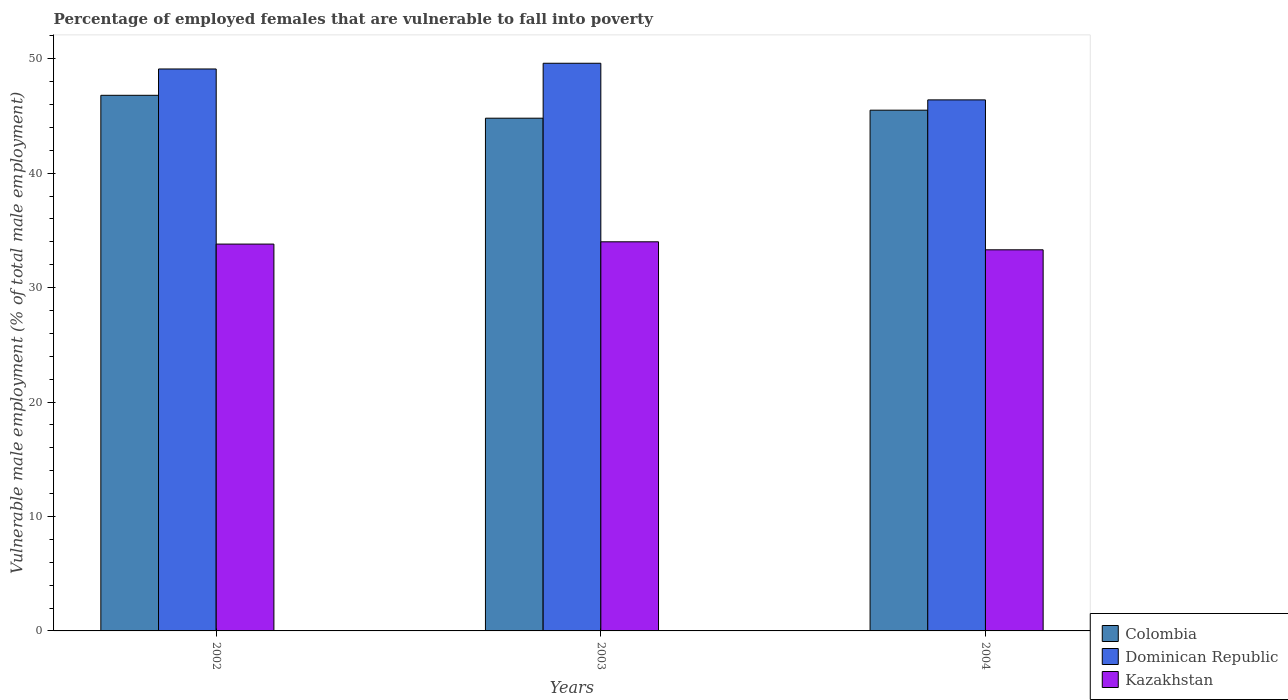How many groups of bars are there?
Your answer should be very brief. 3. Are the number of bars per tick equal to the number of legend labels?
Your response must be concise. Yes. Are the number of bars on each tick of the X-axis equal?
Provide a short and direct response. Yes. How many bars are there on the 3rd tick from the left?
Provide a succinct answer. 3. What is the percentage of employed females who are vulnerable to fall into poverty in Dominican Republic in 2003?
Keep it short and to the point. 49.6. Across all years, what is the minimum percentage of employed females who are vulnerable to fall into poverty in Dominican Republic?
Provide a succinct answer. 46.4. In which year was the percentage of employed females who are vulnerable to fall into poverty in Colombia maximum?
Give a very brief answer. 2002. In which year was the percentage of employed females who are vulnerable to fall into poverty in Dominican Republic minimum?
Make the answer very short. 2004. What is the total percentage of employed females who are vulnerable to fall into poverty in Dominican Republic in the graph?
Ensure brevity in your answer.  145.1. What is the difference between the percentage of employed females who are vulnerable to fall into poverty in Dominican Republic in 2003 and that in 2004?
Keep it short and to the point. 3.2. What is the difference between the percentage of employed females who are vulnerable to fall into poverty in Colombia in 2003 and the percentage of employed females who are vulnerable to fall into poverty in Kazakhstan in 2004?
Your response must be concise. 11.5. What is the average percentage of employed females who are vulnerable to fall into poverty in Colombia per year?
Give a very brief answer. 45.7. In the year 2002, what is the difference between the percentage of employed females who are vulnerable to fall into poverty in Dominican Republic and percentage of employed females who are vulnerable to fall into poverty in Colombia?
Provide a short and direct response. 2.3. In how many years, is the percentage of employed females who are vulnerable to fall into poverty in Kazakhstan greater than 18 %?
Provide a short and direct response. 3. What is the ratio of the percentage of employed females who are vulnerable to fall into poverty in Colombia in 2002 to that in 2004?
Your answer should be very brief. 1.03. What is the difference between the highest and the second highest percentage of employed females who are vulnerable to fall into poverty in Colombia?
Provide a short and direct response. 1.3. In how many years, is the percentage of employed females who are vulnerable to fall into poverty in Dominican Republic greater than the average percentage of employed females who are vulnerable to fall into poverty in Dominican Republic taken over all years?
Offer a terse response. 2. Is the sum of the percentage of employed females who are vulnerable to fall into poverty in Colombia in 2002 and 2003 greater than the maximum percentage of employed females who are vulnerable to fall into poverty in Kazakhstan across all years?
Provide a succinct answer. Yes. What does the 3rd bar from the left in 2004 represents?
Your response must be concise. Kazakhstan. What does the 1st bar from the right in 2003 represents?
Give a very brief answer. Kazakhstan. Is it the case that in every year, the sum of the percentage of employed females who are vulnerable to fall into poverty in Dominican Republic and percentage of employed females who are vulnerable to fall into poverty in Colombia is greater than the percentage of employed females who are vulnerable to fall into poverty in Kazakhstan?
Provide a succinct answer. Yes. What is the difference between two consecutive major ticks on the Y-axis?
Provide a short and direct response. 10. Does the graph contain grids?
Provide a succinct answer. No. How many legend labels are there?
Your response must be concise. 3. What is the title of the graph?
Your answer should be very brief. Percentage of employed females that are vulnerable to fall into poverty. Does "Colombia" appear as one of the legend labels in the graph?
Make the answer very short. Yes. What is the label or title of the Y-axis?
Keep it short and to the point. Vulnerable male employment (% of total male employment). What is the Vulnerable male employment (% of total male employment) of Colombia in 2002?
Your response must be concise. 46.8. What is the Vulnerable male employment (% of total male employment) of Dominican Republic in 2002?
Offer a terse response. 49.1. What is the Vulnerable male employment (% of total male employment) of Kazakhstan in 2002?
Provide a short and direct response. 33.8. What is the Vulnerable male employment (% of total male employment) of Colombia in 2003?
Give a very brief answer. 44.8. What is the Vulnerable male employment (% of total male employment) of Dominican Republic in 2003?
Provide a succinct answer. 49.6. What is the Vulnerable male employment (% of total male employment) of Colombia in 2004?
Ensure brevity in your answer.  45.5. What is the Vulnerable male employment (% of total male employment) of Dominican Republic in 2004?
Offer a terse response. 46.4. What is the Vulnerable male employment (% of total male employment) in Kazakhstan in 2004?
Provide a succinct answer. 33.3. Across all years, what is the maximum Vulnerable male employment (% of total male employment) of Colombia?
Keep it short and to the point. 46.8. Across all years, what is the maximum Vulnerable male employment (% of total male employment) in Dominican Republic?
Give a very brief answer. 49.6. Across all years, what is the minimum Vulnerable male employment (% of total male employment) of Colombia?
Provide a short and direct response. 44.8. Across all years, what is the minimum Vulnerable male employment (% of total male employment) of Dominican Republic?
Your answer should be compact. 46.4. Across all years, what is the minimum Vulnerable male employment (% of total male employment) of Kazakhstan?
Give a very brief answer. 33.3. What is the total Vulnerable male employment (% of total male employment) of Colombia in the graph?
Give a very brief answer. 137.1. What is the total Vulnerable male employment (% of total male employment) in Dominican Republic in the graph?
Your answer should be compact. 145.1. What is the total Vulnerable male employment (% of total male employment) of Kazakhstan in the graph?
Your answer should be very brief. 101.1. What is the difference between the Vulnerable male employment (% of total male employment) in Dominican Republic in 2002 and that in 2003?
Offer a very short reply. -0.5. What is the difference between the Vulnerable male employment (% of total male employment) of Kazakhstan in 2002 and that in 2003?
Your answer should be compact. -0.2. What is the difference between the Vulnerable male employment (% of total male employment) in Dominican Republic in 2002 and that in 2004?
Offer a terse response. 2.7. What is the difference between the Vulnerable male employment (% of total male employment) in Kazakhstan in 2002 and that in 2004?
Give a very brief answer. 0.5. What is the difference between the Vulnerable male employment (% of total male employment) of Colombia in 2003 and that in 2004?
Ensure brevity in your answer.  -0.7. What is the difference between the Vulnerable male employment (% of total male employment) in Kazakhstan in 2003 and that in 2004?
Give a very brief answer. 0.7. What is the difference between the Vulnerable male employment (% of total male employment) of Colombia in 2002 and the Vulnerable male employment (% of total male employment) of Dominican Republic in 2003?
Ensure brevity in your answer.  -2.8. What is the difference between the Vulnerable male employment (% of total male employment) of Colombia in 2002 and the Vulnerable male employment (% of total male employment) of Dominican Republic in 2004?
Make the answer very short. 0.4. What is the difference between the Vulnerable male employment (% of total male employment) in Colombia in 2002 and the Vulnerable male employment (% of total male employment) in Kazakhstan in 2004?
Keep it short and to the point. 13.5. What is the difference between the Vulnerable male employment (% of total male employment) of Dominican Republic in 2002 and the Vulnerable male employment (% of total male employment) of Kazakhstan in 2004?
Offer a terse response. 15.8. What is the difference between the Vulnerable male employment (% of total male employment) of Colombia in 2003 and the Vulnerable male employment (% of total male employment) of Dominican Republic in 2004?
Offer a very short reply. -1.6. What is the difference between the Vulnerable male employment (% of total male employment) of Colombia in 2003 and the Vulnerable male employment (% of total male employment) of Kazakhstan in 2004?
Ensure brevity in your answer.  11.5. What is the difference between the Vulnerable male employment (% of total male employment) of Dominican Republic in 2003 and the Vulnerable male employment (% of total male employment) of Kazakhstan in 2004?
Give a very brief answer. 16.3. What is the average Vulnerable male employment (% of total male employment) of Colombia per year?
Your answer should be very brief. 45.7. What is the average Vulnerable male employment (% of total male employment) of Dominican Republic per year?
Provide a short and direct response. 48.37. What is the average Vulnerable male employment (% of total male employment) in Kazakhstan per year?
Your answer should be very brief. 33.7. In the year 2003, what is the difference between the Vulnerable male employment (% of total male employment) of Colombia and Vulnerable male employment (% of total male employment) of Kazakhstan?
Offer a very short reply. 10.8. In the year 2003, what is the difference between the Vulnerable male employment (% of total male employment) in Dominican Republic and Vulnerable male employment (% of total male employment) in Kazakhstan?
Make the answer very short. 15.6. In the year 2004, what is the difference between the Vulnerable male employment (% of total male employment) in Colombia and Vulnerable male employment (% of total male employment) in Dominican Republic?
Your answer should be compact. -0.9. In the year 2004, what is the difference between the Vulnerable male employment (% of total male employment) of Colombia and Vulnerable male employment (% of total male employment) of Kazakhstan?
Your answer should be compact. 12.2. In the year 2004, what is the difference between the Vulnerable male employment (% of total male employment) in Dominican Republic and Vulnerable male employment (% of total male employment) in Kazakhstan?
Your answer should be compact. 13.1. What is the ratio of the Vulnerable male employment (% of total male employment) in Colombia in 2002 to that in 2003?
Your answer should be compact. 1.04. What is the ratio of the Vulnerable male employment (% of total male employment) of Kazakhstan in 2002 to that in 2003?
Your answer should be compact. 0.99. What is the ratio of the Vulnerable male employment (% of total male employment) in Colombia in 2002 to that in 2004?
Provide a succinct answer. 1.03. What is the ratio of the Vulnerable male employment (% of total male employment) in Dominican Republic in 2002 to that in 2004?
Give a very brief answer. 1.06. What is the ratio of the Vulnerable male employment (% of total male employment) of Colombia in 2003 to that in 2004?
Offer a very short reply. 0.98. What is the ratio of the Vulnerable male employment (% of total male employment) in Dominican Republic in 2003 to that in 2004?
Provide a succinct answer. 1.07. What is the difference between the highest and the second highest Vulnerable male employment (% of total male employment) of Dominican Republic?
Offer a terse response. 0.5. What is the difference between the highest and the second highest Vulnerable male employment (% of total male employment) of Kazakhstan?
Offer a very short reply. 0.2. What is the difference between the highest and the lowest Vulnerable male employment (% of total male employment) of Colombia?
Give a very brief answer. 2. What is the difference between the highest and the lowest Vulnerable male employment (% of total male employment) of Dominican Republic?
Your response must be concise. 3.2. What is the difference between the highest and the lowest Vulnerable male employment (% of total male employment) in Kazakhstan?
Ensure brevity in your answer.  0.7. 